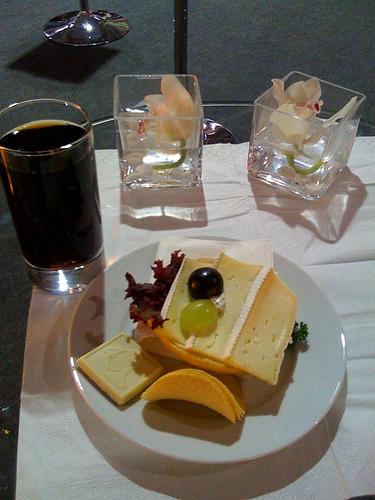How many cups?
Write a very short answer. 3. What is the flavor of the drink?
Keep it brief. Coke. Does the plate have a pattern on it?
Write a very short answer. No. What fruit is on the plate?
Be succinct. Grapes. Do you see a drink?
Give a very brief answer. Yes. Are there grapes in the photo?
Be succinct. Yes. What color is the plate?
Give a very brief answer. White. 